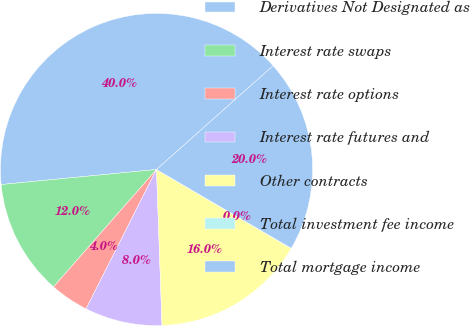Convert chart. <chart><loc_0><loc_0><loc_500><loc_500><pie_chart><fcel>Derivatives Not Designated as<fcel>Interest rate swaps<fcel>Interest rate options<fcel>Interest rate futures and<fcel>Other contracts<fcel>Total investment fee income<fcel>Total mortgage income<nl><fcel>39.96%<fcel>12.0%<fcel>4.01%<fcel>8.01%<fcel>16.0%<fcel>0.02%<fcel>19.99%<nl></chart> 